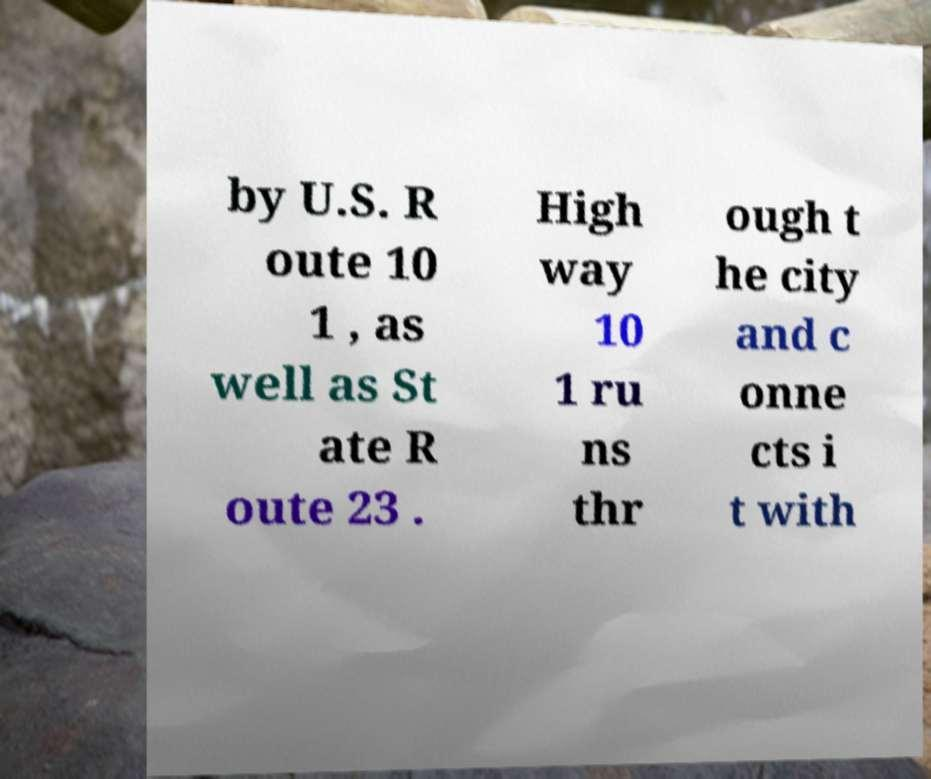Can you accurately transcribe the text from the provided image for me? by U.S. R oute 10 1 , as well as St ate R oute 23 . High way 10 1 ru ns thr ough t he city and c onne cts i t with 